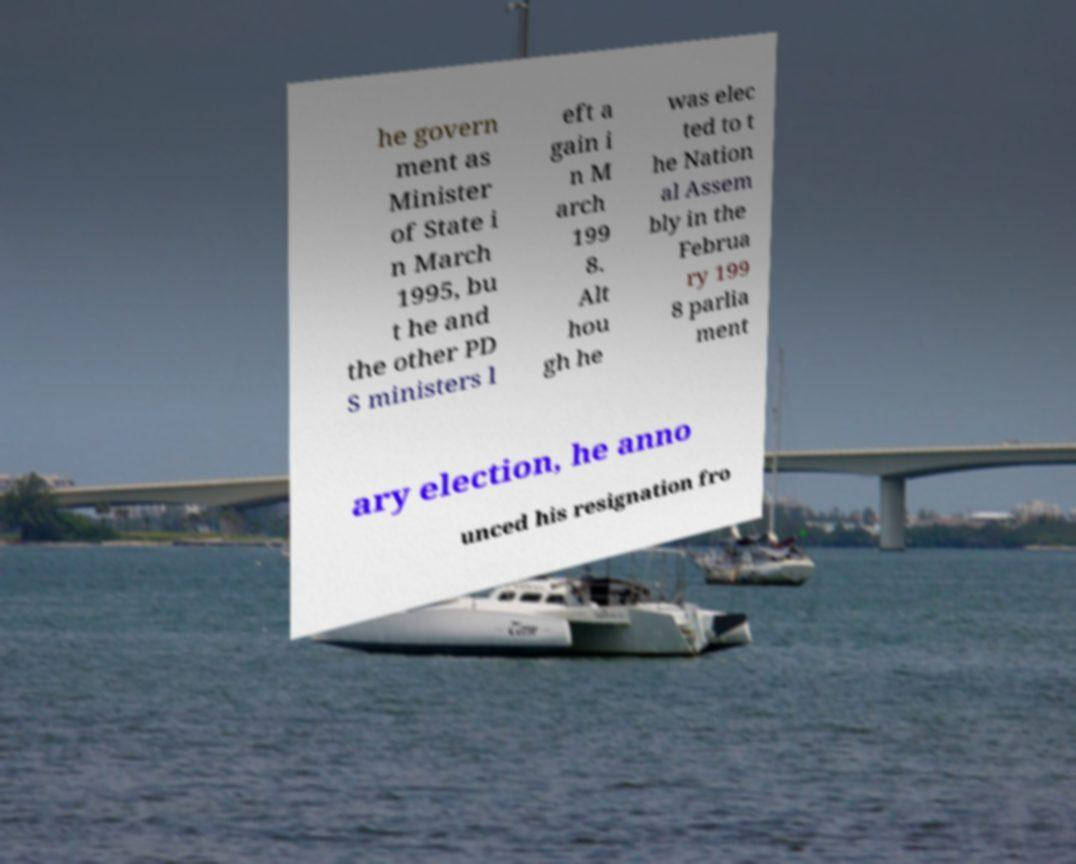Please identify and transcribe the text found in this image. he govern ment as Minister of State i n March 1995, bu t he and the other PD S ministers l eft a gain i n M arch 199 8. Alt hou gh he was elec ted to t he Nation al Assem bly in the Februa ry 199 8 parlia ment ary election, he anno unced his resignation fro 